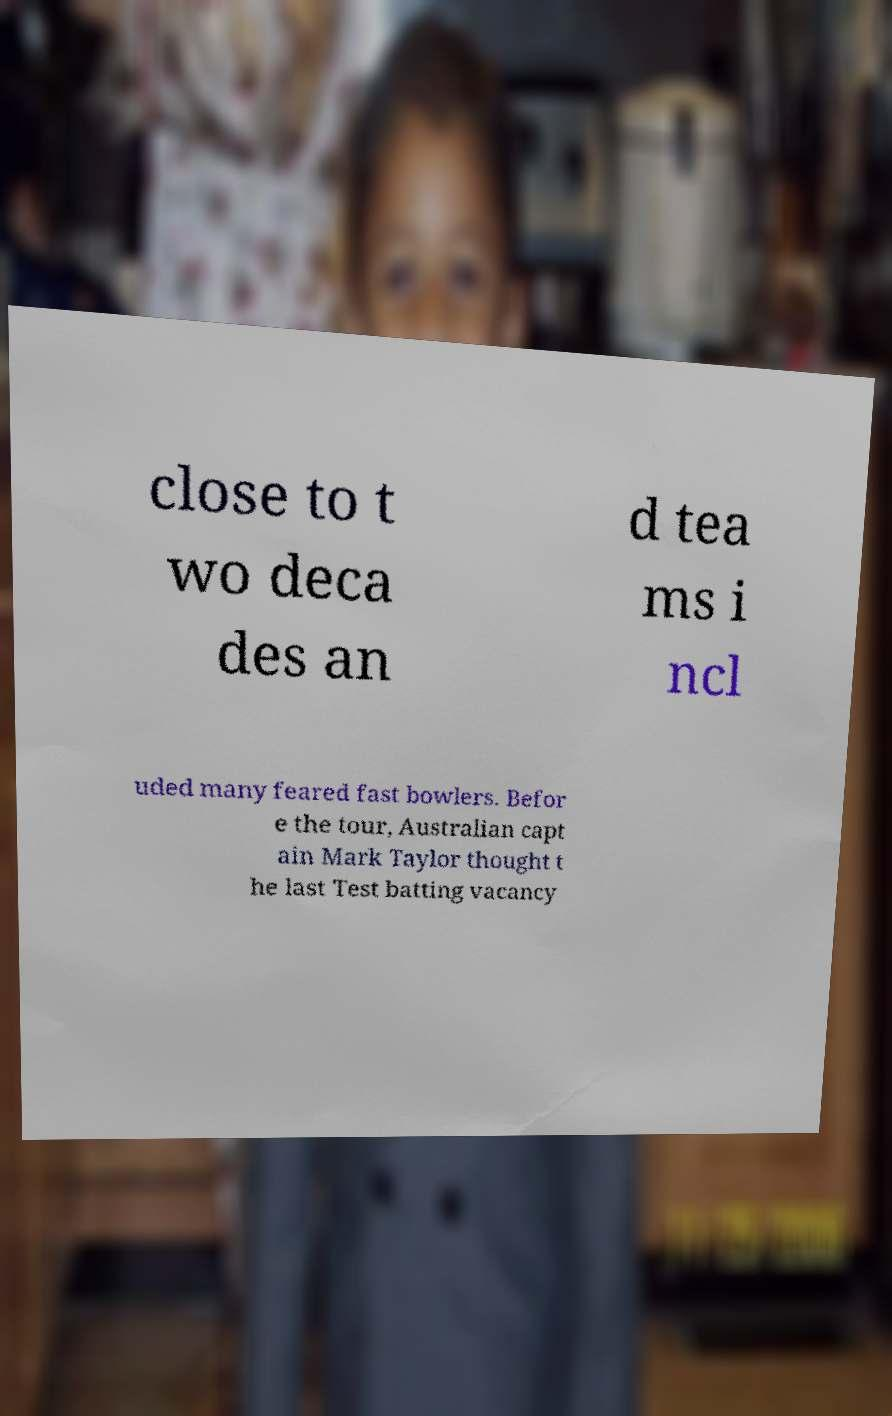Please read and relay the text visible in this image. What does it say? close to t wo deca des an d tea ms i ncl uded many feared fast bowlers. Befor e the tour, Australian capt ain Mark Taylor thought t he last Test batting vacancy 